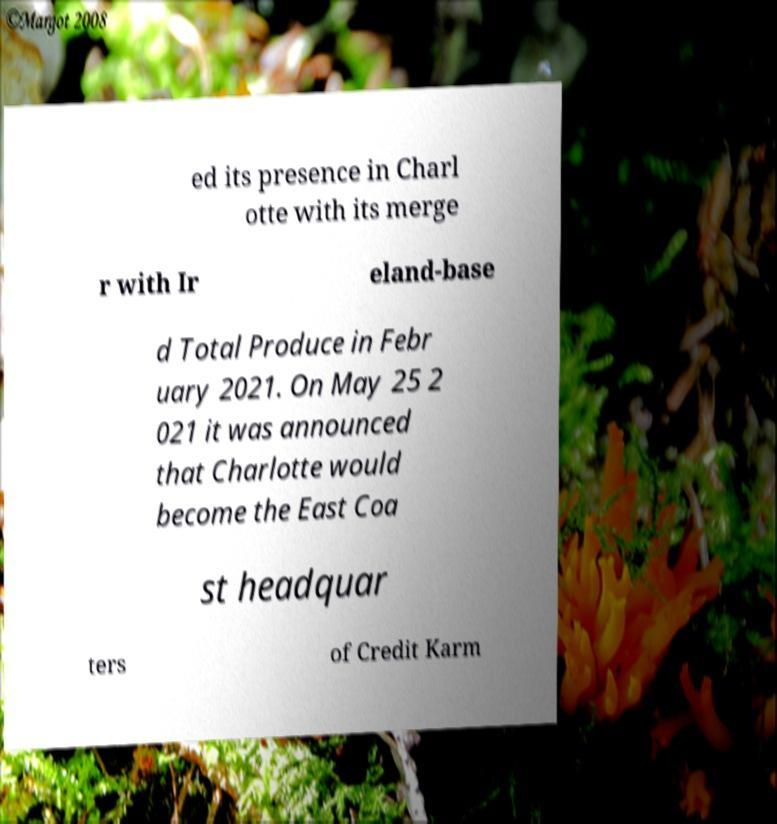Could you assist in decoding the text presented in this image and type it out clearly? ed its presence in Charl otte with its merge r with Ir eland-base d Total Produce in Febr uary 2021. On May 25 2 021 it was announced that Charlotte would become the East Coa st headquar ters of Credit Karm 